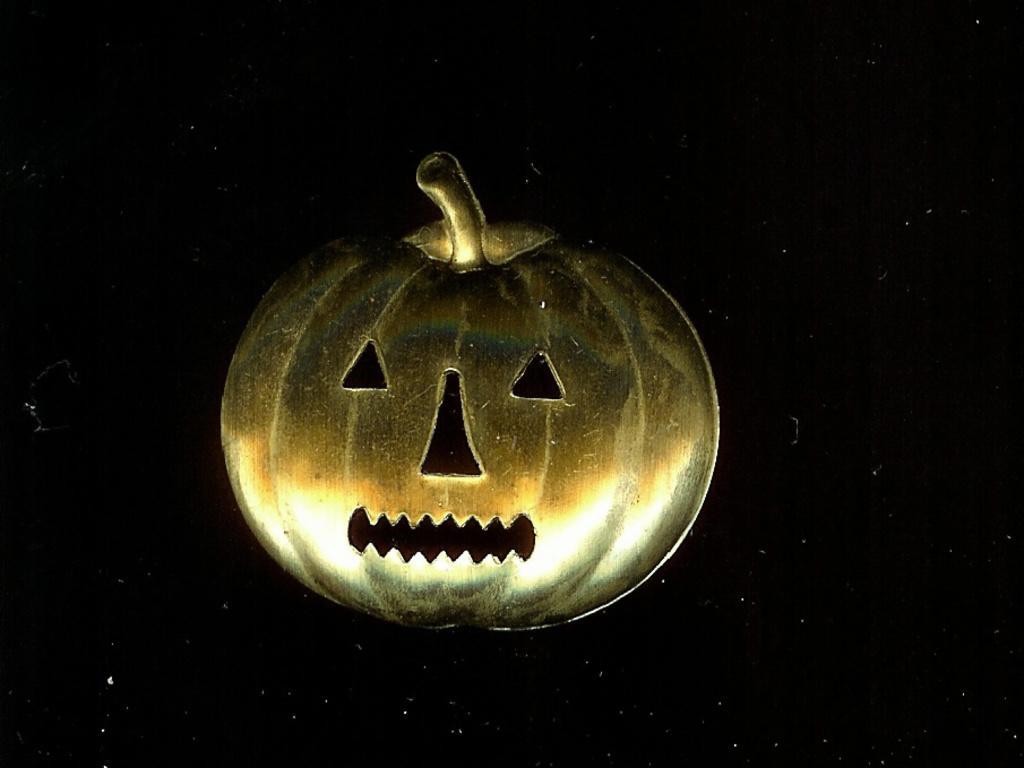In one or two sentences, can you explain what this image depicts? In the center of the image there is a depiction of a pumpkin. 